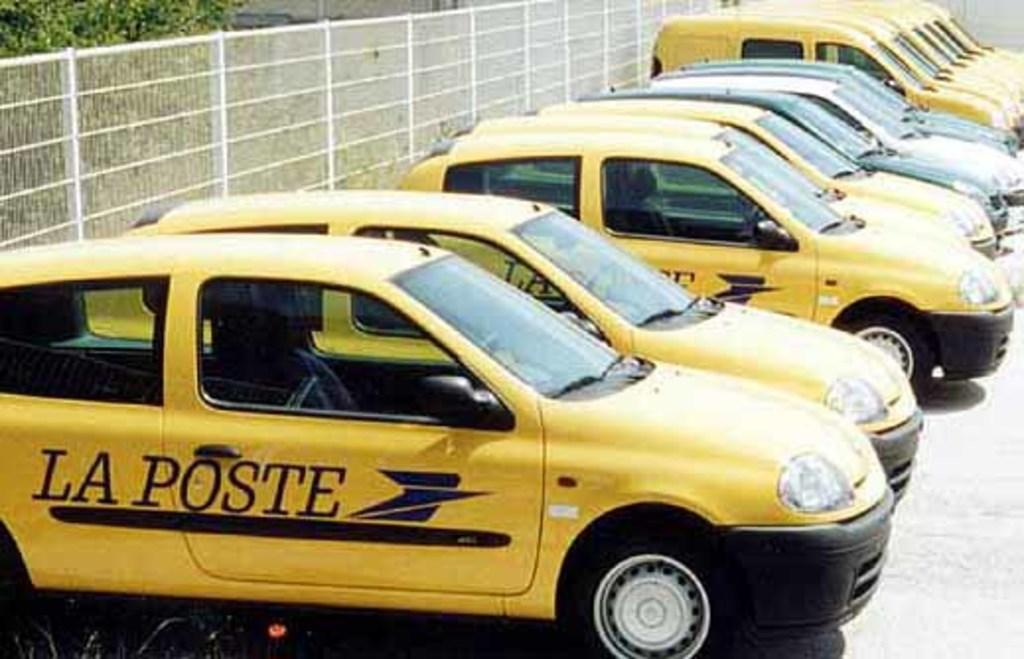<image>
Render a clear and concise summary of the photo. Bunch of yellow La Poste taxi cabs parked outside on a sunny day. 